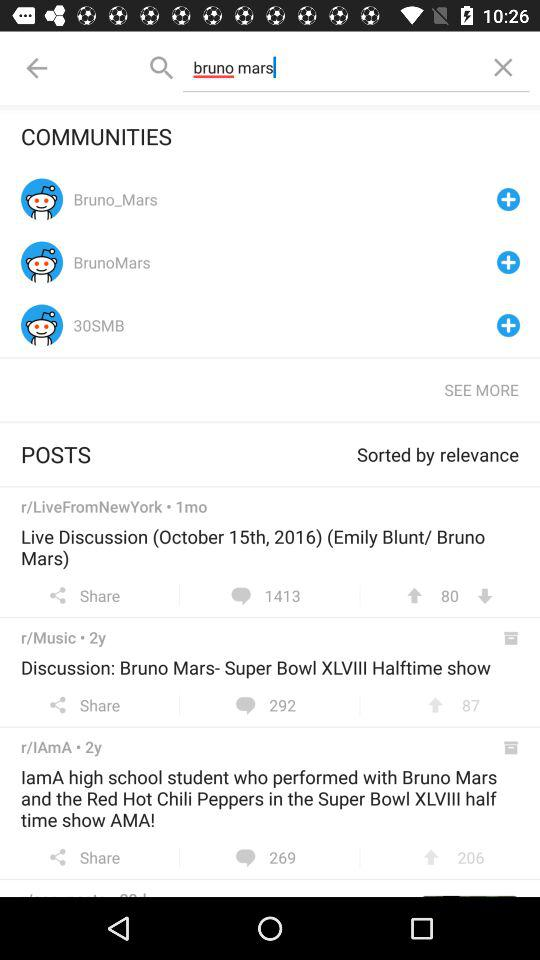What is the live discussion date? The date is October 15, 2016. 